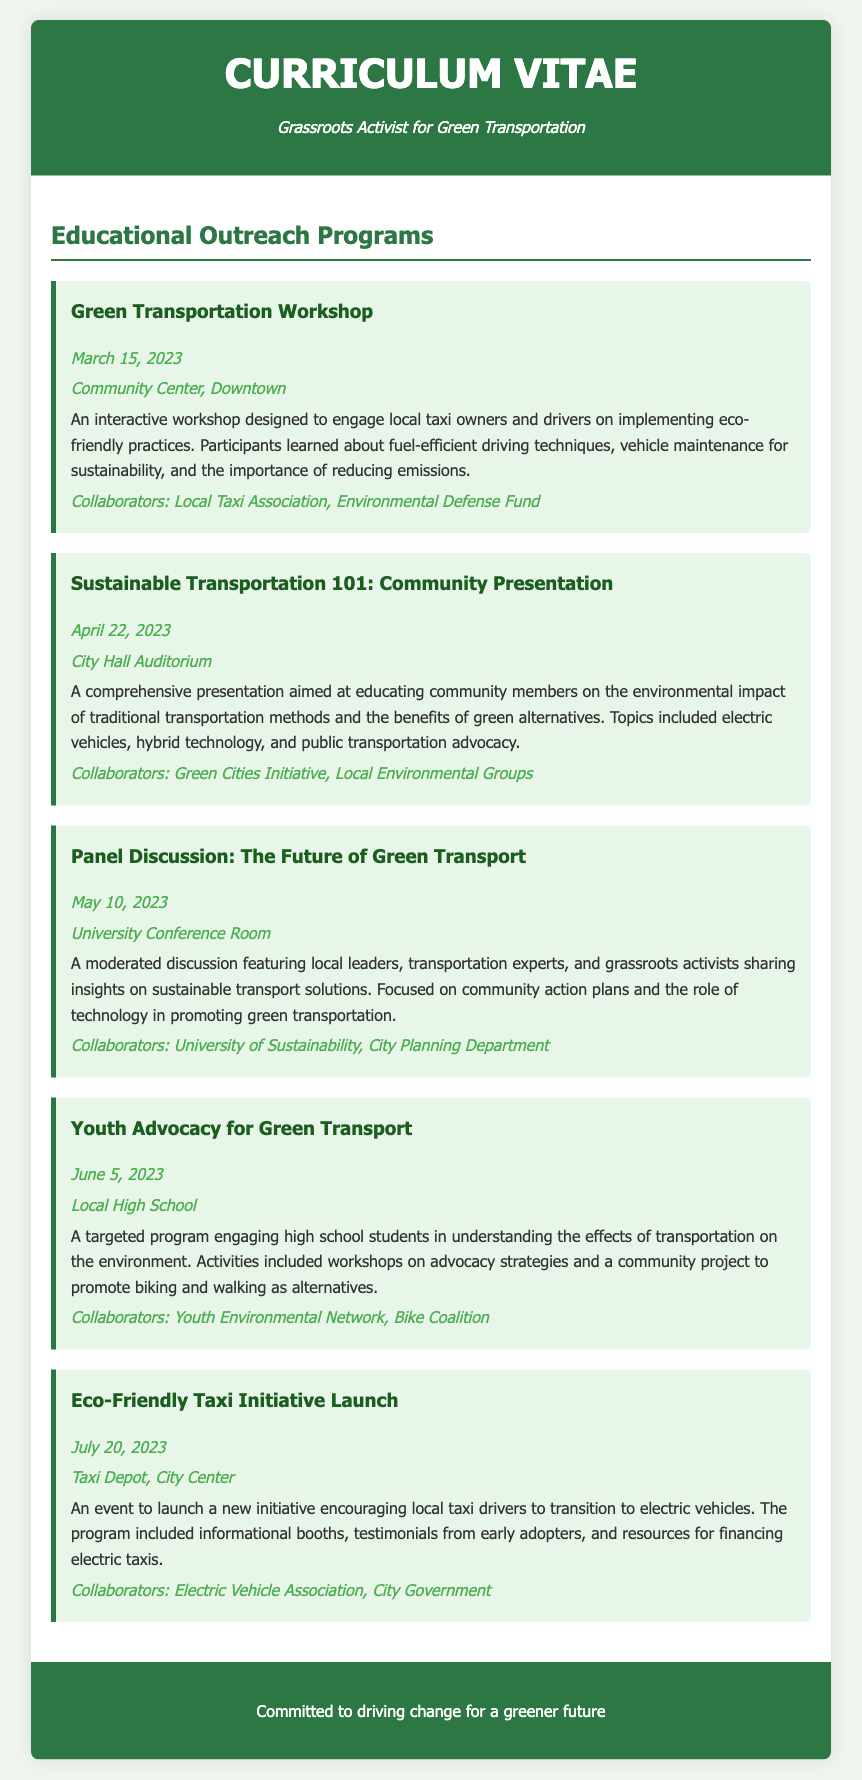what is the date of the Green Transportation Workshop? The date is specifically mentioned in the document under that program.
Answer: March 15, 2023 where was the Sustainable Transportation 101 presentation held? The location is stated in the details of that event within the document.
Answer: City Hall Auditorium who collaborated on the Youth Advocacy for Green Transport program? The collaborators are listed in the details of this program in the document.
Answer: Youth Environmental Network, Bike Coalition what was the focus of the Panel Discussion: The Future of Green Transport? The main theme or focus is described in the program description in the document.
Answer: Community action plans and the role of technology how many workshops and presentations are listed in the document? The total number of such events is mentioned through the individual programs detailed.
Answer: Five 